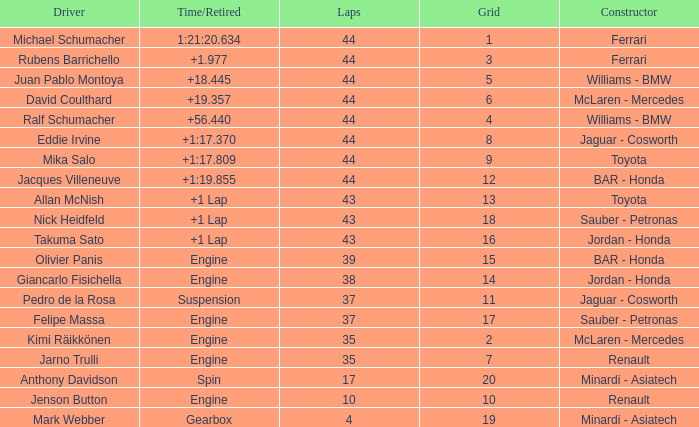What was the retired time on someone who had 43 laps on a grip of 18? +1 Lap. 